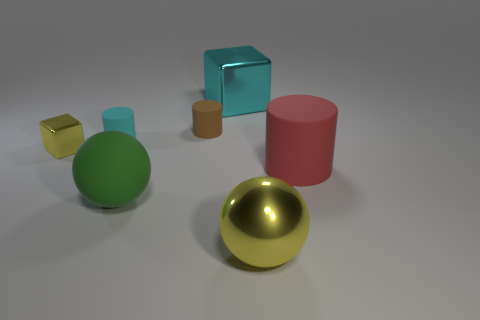Subtract all brown cylinders. How many cylinders are left? 2 Add 3 metallic things. How many objects exist? 10 Subtract all green spheres. How many spheres are left? 1 Subtract all blocks. How many objects are left? 5 Subtract 0 cyan spheres. How many objects are left? 7 Subtract all gray blocks. Subtract all brown cylinders. How many blocks are left? 2 Subtract all gray cylinders. How many red balls are left? 0 Subtract all large red rubber cylinders. Subtract all metal spheres. How many objects are left? 5 Add 4 small brown rubber objects. How many small brown rubber objects are left? 5 Add 1 yellow blocks. How many yellow blocks exist? 2 